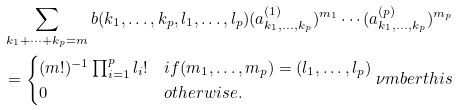Convert formula to latex. <formula><loc_0><loc_0><loc_500><loc_500>& \sum _ { k _ { 1 } + \dots + k _ { p } = m } b ( k _ { 1 } , \dots , k _ { p } , l _ { 1 } , \dots , l _ { p } ) ( a _ { k _ { 1 } , \dots , k _ { p } } ^ { ( 1 ) } ) ^ { m _ { 1 } } \cdots ( a _ { k _ { 1 } , \dots , k _ { p } } ^ { ( p ) } ) ^ { m _ { p } } \\ & = \begin{cases} ( m ! ) ^ { - 1 } \prod _ { i = 1 } ^ { p } l _ { i } ! & i f ( m _ { 1 } , \dots , m _ { p } ) = ( l _ { 1 } , \dots , l _ { p } ) \\ 0 & o t h e r w i s e . \end{cases} \nu m b e r t h i s</formula> 